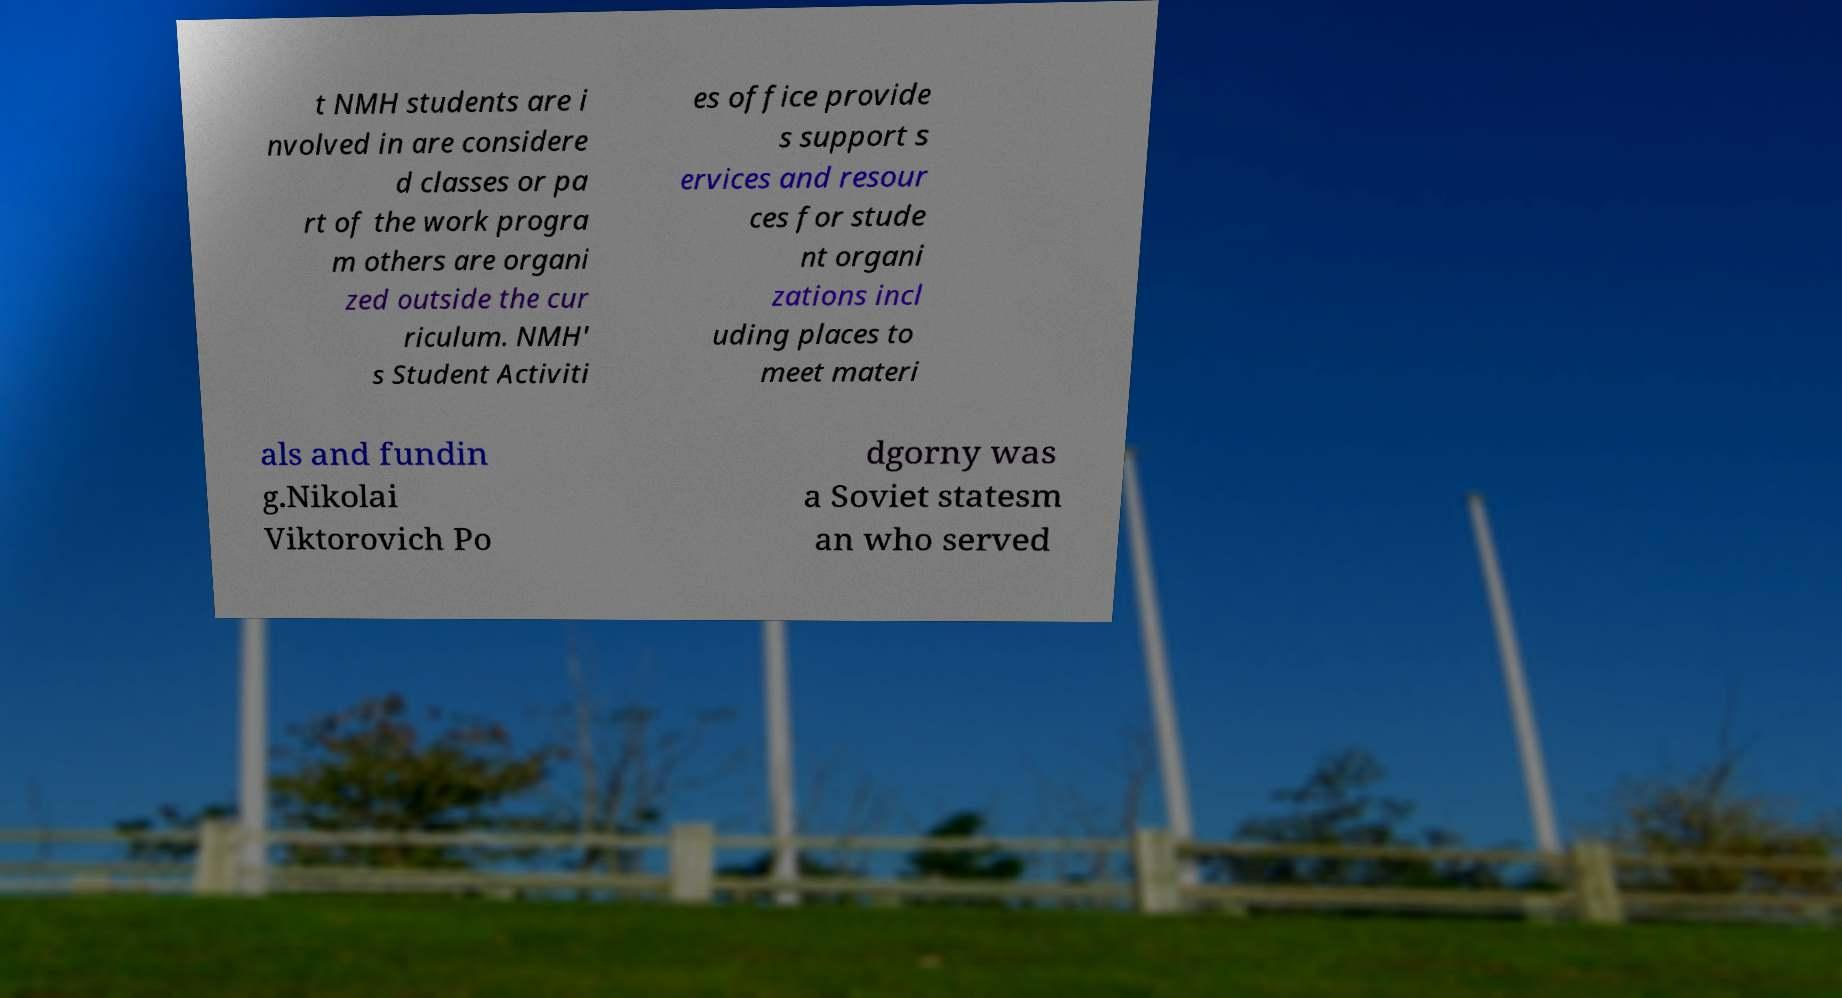Please identify and transcribe the text found in this image. t NMH students are i nvolved in are considere d classes or pa rt of the work progra m others are organi zed outside the cur riculum. NMH' s Student Activiti es office provide s support s ervices and resour ces for stude nt organi zations incl uding places to meet materi als and fundin g.Nikolai Viktorovich Po dgorny was a Soviet statesm an who served 